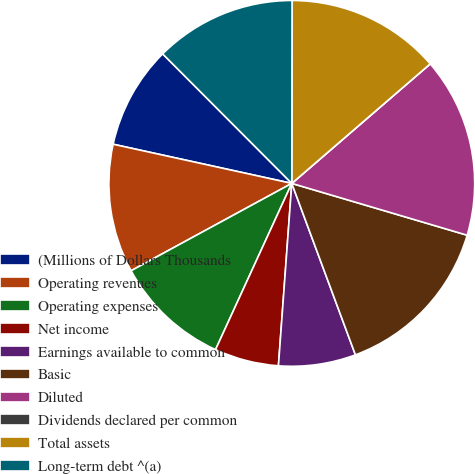Convert chart. <chart><loc_0><loc_0><loc_500><loc_500><pie_chart><fcel>(Millions of Dollars Thousands<fcel>Operating revenues<fcel>Operating expenses<fcel>Net income<fcel>Earnings available to common<fcel>Basic<fcel>Diluted<fcel>Dividends declared per common<fcel>Total assets<fcel>Long-term debt ^(a)<nl><fcel>9.09%<fcel>11.36%<fcel>10.23%<fcel>5.68%<fcel>6.82%<fcel>14.77%<fcel>15.91%<fcel>0.0%<fcel>13.64%<fcel>12.5%<nl></chart> 